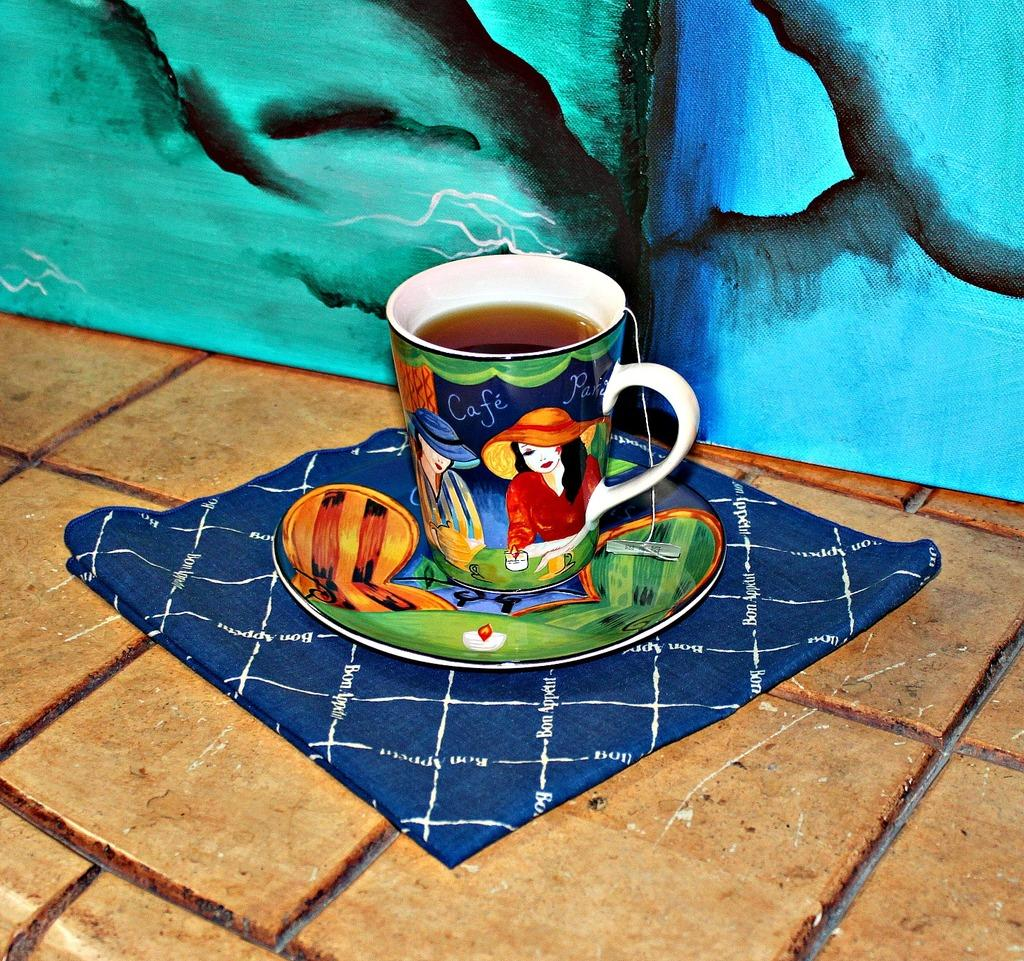What is located in the middle of the image? There is a cloth in the middle of the image. What is placed on the cloth? There is a plate and a cup with liquid content on the cloth. What can be seen in the background of the image? There is a painting on the wall in the background of the image. How many eyes can be seen on the cloth in the image? There are no eyes visible on the cloth in the image. What type of crack is present in the cup in the image? There is no crack present in the cup in the image; it appears to be in good condition. 